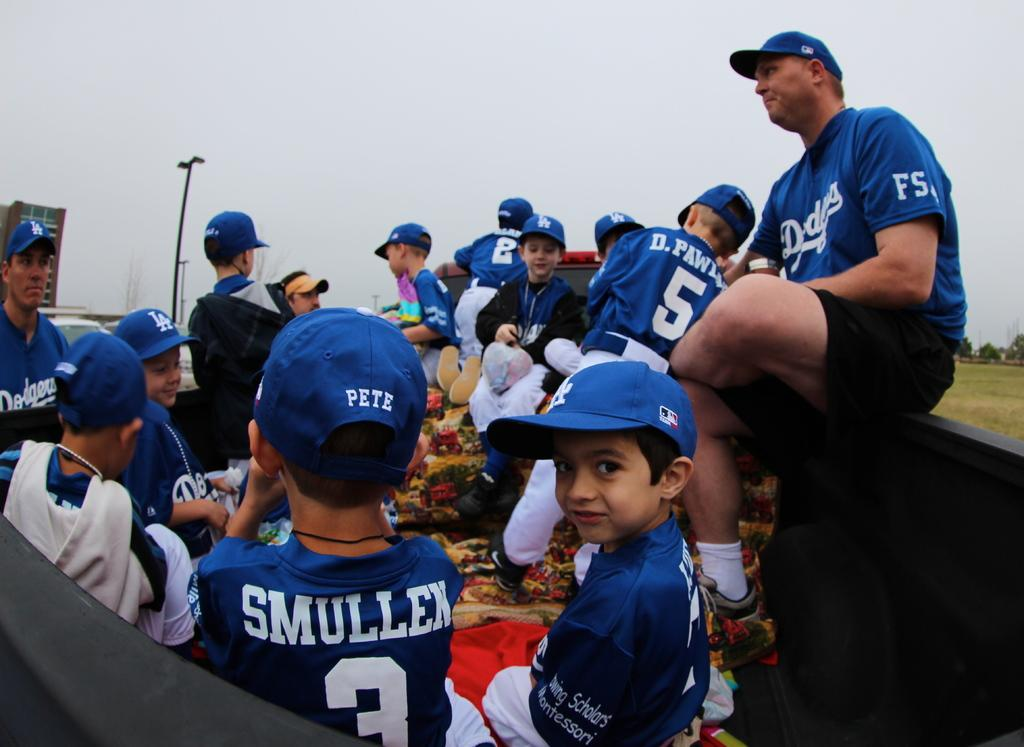<image>
Write a terse but informative summary of the picture. A baseball team in blue Dogers uniforms on with player number 3 looking in front of him with the name Pete on the back of his hat. 